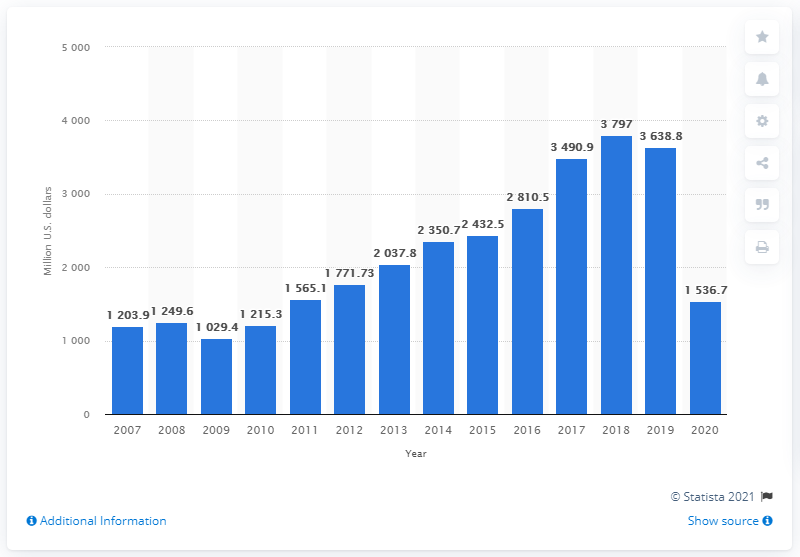Specify some key components in this picture. In 2020, the total revenue of Samsonite in the United States was 1536.7 million dollars. 